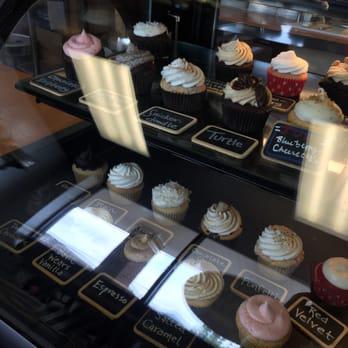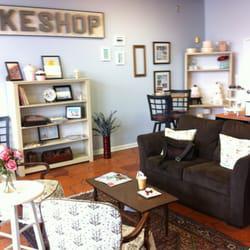The first image is the image on the left, the second image is the image on the right. Analyze the images presented: Is the assertion "An image shows a female worker by a glass case, wearing a scarf on her head." valid? Answer yes or no. No. The first image is the image on the left, the second image is the image on the right. Considering the images on both sides, is "a woman behind the counter is wearing a head wrap." valid? Answer yes or no. No. 